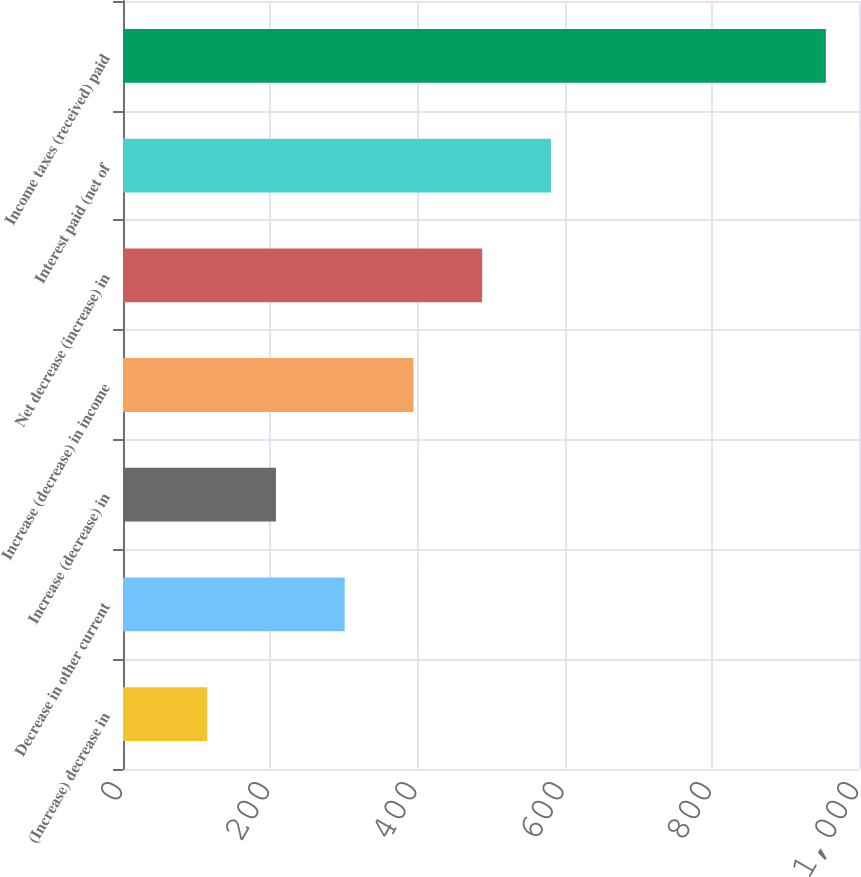Convert chart. <chart><loc_0><loc_0><loc_500><loc_500><bar_chart><fcel>(Increase) decrease in<fcel>Decrease in other current<fcel>Increase (decrease) in<fcel>Increase (decrease) in income<fcel>Net decrease (increase) in<fcel>Interest paid (net of<fcel>Income taxes (received) paid<nl><fcel>114.4<fcel>301.2<fcel>207.8<fcel>394.6<fcel>488<fcel>581.4<fcel>955<nl></chart> 